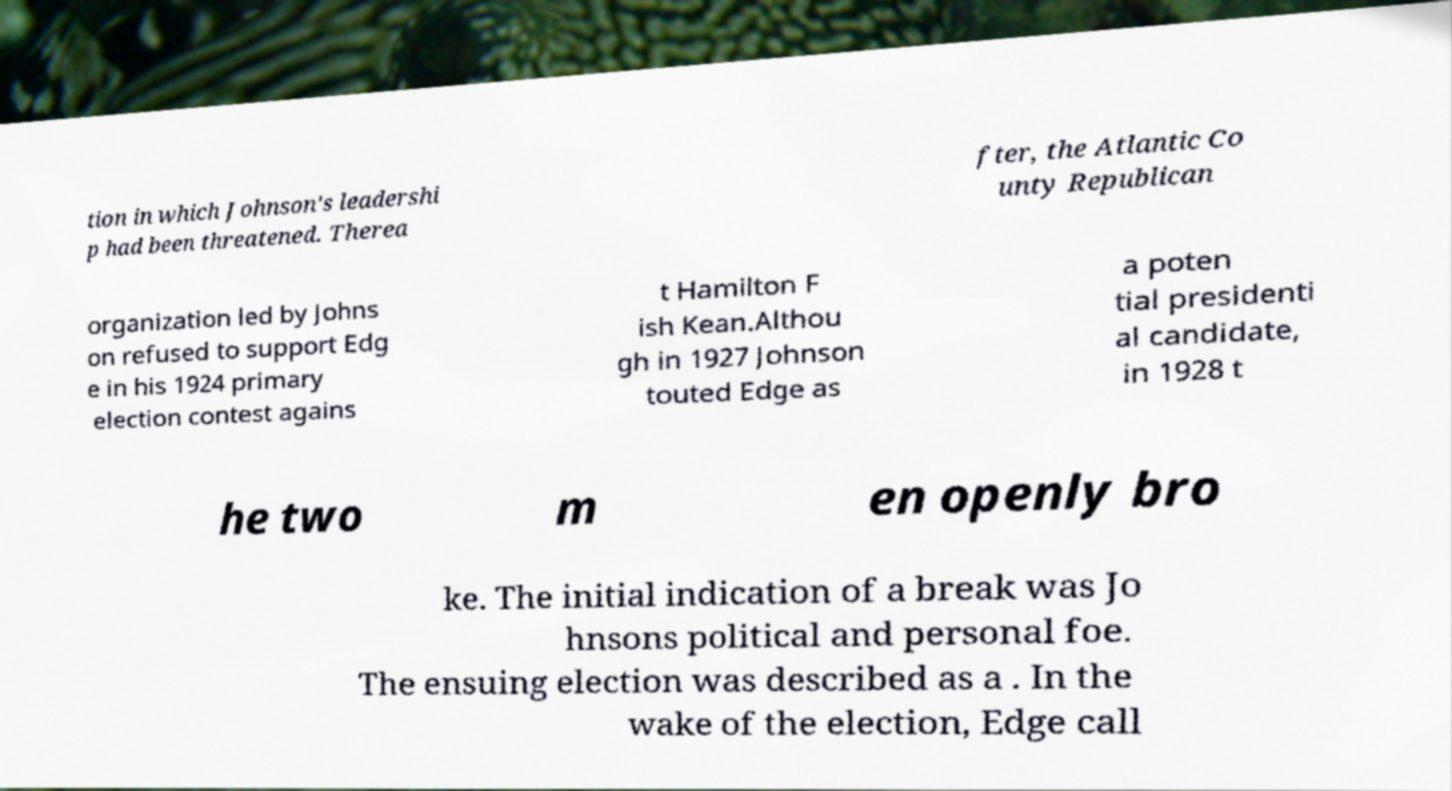Could you extract and type out the text from this image? tion in which Johnson's leadershi p had been threatened. Therea fter, the Atlantic Co unty Republican organization led by Johns on refused to support Edg e in his 1924 primary election contest agains t Hamilton F ish Kean.Althou gh in 1927 Johnson touted Edge as a poten tial presidenti al candidate, in 1928 t he two m en openly bro ke. The initial indication of a break was Jo hnsons political and personal foe. The ensuing election was described as a . In the wake of the election, Edge call 